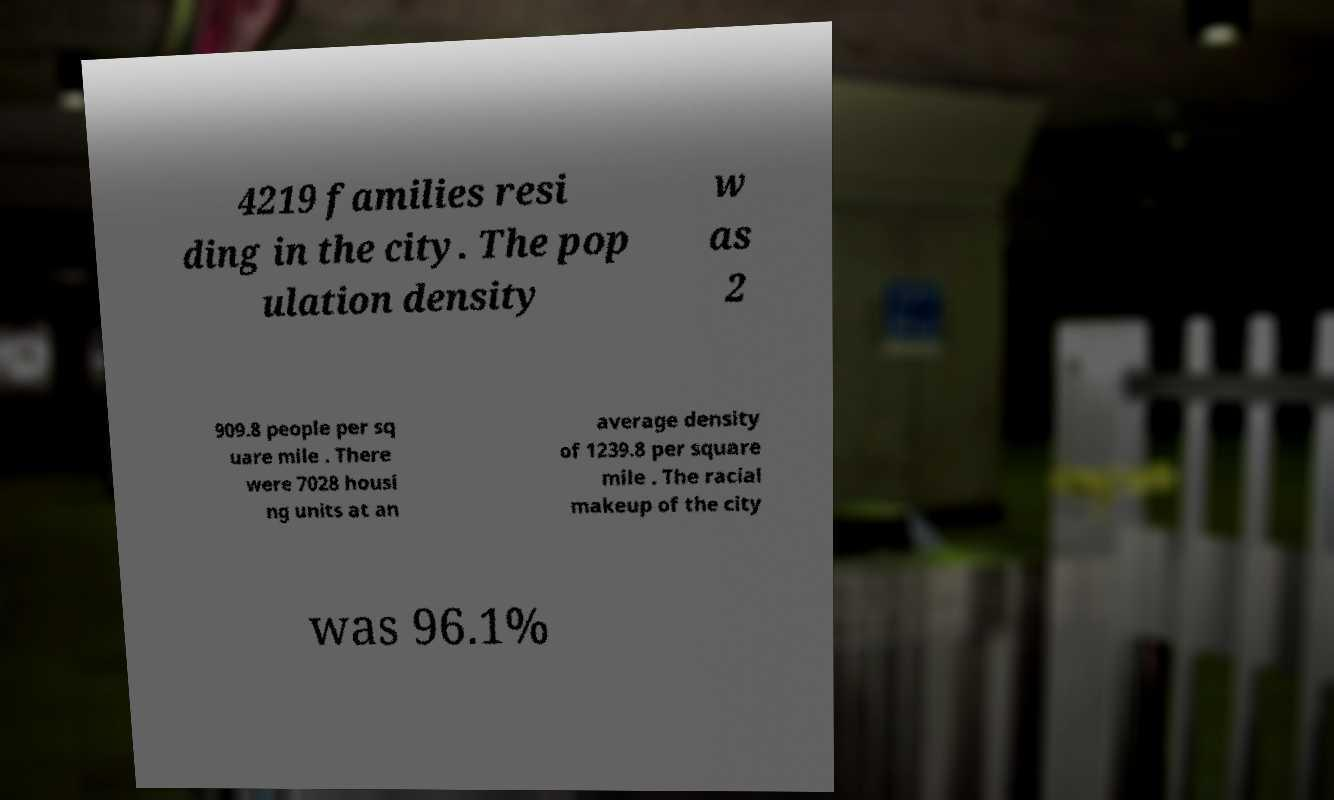There's text embedded in this image that I need extracted. Can you transcribe it verbatim? 4219 families resi ding in the city. The pop ulation density w as 2 909.8 people per sq uare mile . There were 7028 housi ng units at an average density of 1239.8 per square mile . The racial makeup of the city was 96.1% 